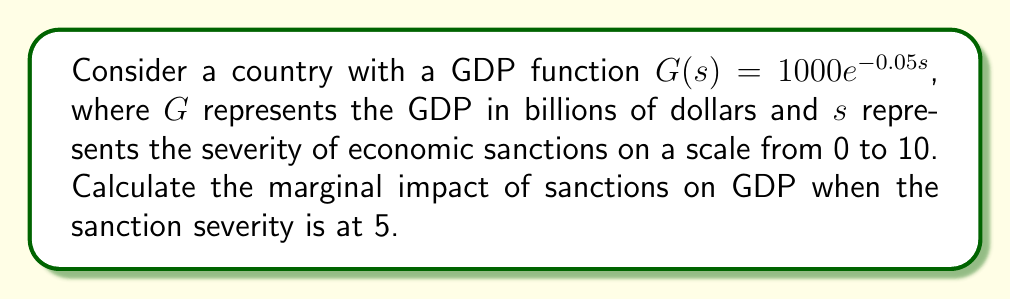Can you answer this question? To solve this problem, we need to follow these steps:

1) The marginal impact of sanctions on GDP is represented by the derivative of the GDP function with respect to the sanction severity.

2) Given: $G(s) = 1000e^{-0.05s}$

3) To find the derivative, we use the chain rule:

   $$\frac{dG}{ds} = 1000 \cdot (-0.05) \cdot e^{-0.05s}$$

4) Simplify:

   $$\frac{dG}{ds} = -50e^{-0.05s}$$

5) This derivative represents the rate of change of GDP with respect to sanction severity at any point.

6) To find the marginal impact when sanction severity is 5, we substitute $s = 5$ into our derivative:

   $$\frac{dG}{ds}\bigg|_{s=5} = -50e^{-0.05(5)} = -50e^{-0.25}$$

7) Calculate:

   $$-50e^{-0.25} \approx -38.94$$

8) Interpret: When the sanction severity is at 5, an incremental increase in sanctions will cause the GDP to decrease by approximately 38.94 billion dollars.

This analysis could be particularly relevant for an international affairs student studying the economic impacts of diplomatic actions.
Answer: $-38.94$ billion dollars 